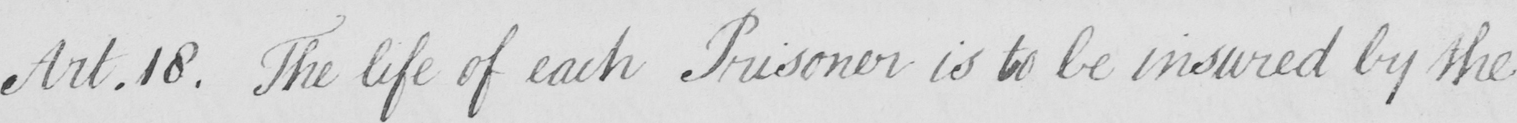Please provide the text content of this handwritten line. Art . 18 . The life of each Prisoner is to be insured by the 